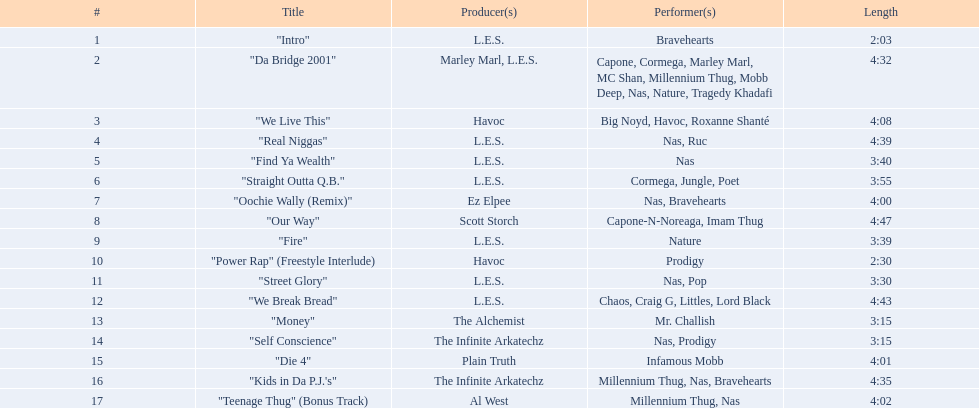What is the duration of each track? 2:03, 4:32, 4:08, 4:39, 3:40, 3:55, 4:00, 4:47, 3:39, 2:30, 3:30, 4:43, 3:15, 3:15, 4:01, 4:35, 4:02. What is the longest track's length? 4:47. 